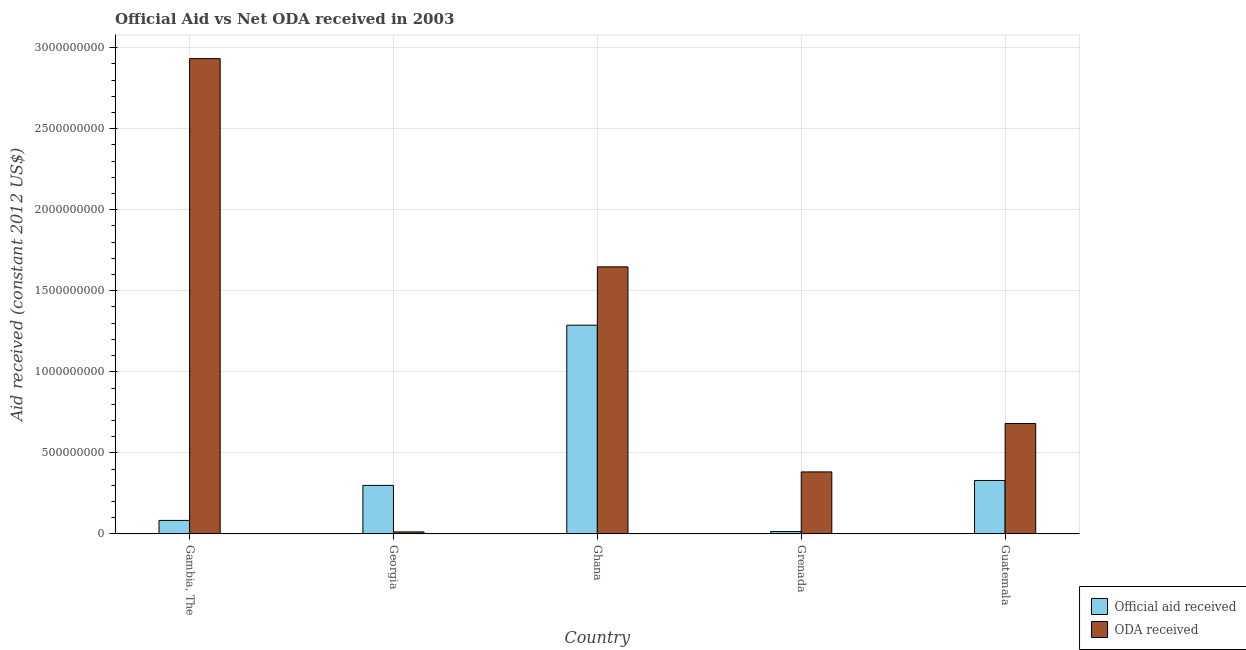How many different coloured bars are there?
Your response must be concise. 2. How many groups of bars are there?
Make the answer very short. 5. Are the number of bars per tick equal to the number of legend labels?
Your response must be concise. Yes. How many bars are there on the 4th tick from the left?
Provide a succinct answer. 2. What is the label of the 4th group of bars from the left?
Offer a terse response. Grenada. What is the official aid received in Grenada?
Make the answer very short. 1.42e+07. Across all countries, what is the maximum official aid received?
Provide a short and direct response. 1.29e+09. Across all countries, what is the minimum official aid received?
Provide a short and direct response. 1.42e+07. In which country was the oda received maximum?
Your answer should be very brief. Gambia, The. In which country was the oda received minimum?
Your answer should be very brief. Georgia. What is the total oda received in the graph?
Your response must be concise. 5.66e+09. What is the difference between the official aid received in Georgia and that in Guatemala?
Provide a short and direct response. -3.03e+07. What is the difference between the oda received in Gambia, The and the official aid received in Ghana?
Your answer should be compact. 1.64e+09. What is the average oda received per country?
Provide a short and direct response. 1.13e+09. What is the difference between the official aid received and oda received in Ghana?
Your answer should be very brief. -3.60e+08. In how many countries, is the official aid received greater than 200000000 US$?
Your response must be concise. 3. What is the ratio of the official aid received in Ghana to that in Guatemala?
Your answer should be compact. 3.91. Is the oda received in Georgia less than that in Ghana?
Make the answer very short. Yes. Is the difference between the official aid received in Georgia and Grenada greater than the difference between the oda received in Georgia and Grenada?
Offer a terse response. Yes. What is the difference between the highest and the second highest official aid received?
Provide a succinct answer. 9.58e+08. What is the difference between the highest and the lowest oda received?
Your response must be concise. 2.92e+09. Is the sum of the oda received in Georgia and Grenada greater than the maximum official aid received across all countries?
Your response must be concise. No. What does the 1st bar from the left in Ghana represents?
Ensure brevity in your answer.  Official aid received. What does the 2nd bar from the right in Ghana represents?
Ensure brevity in your answer.  Official aid received. Where does the legend appear in the graph?
Your answer should be very brief. Bottom right. How many legend labels are there?
Your response must be concise. 2. What is the title of the graph?
Provide a short and direct response. Official Aid vs Net ODA received in 2003 . Does "Food" appear as one of the legend labels in the graph?
Your answer should be very brief. No. What is the label or title of the Y-axis?
Offer a very short reply. Aid received (constant 2012 US$). What is the Aid received (constant 2012 US$) of Official aid received in Gambia, The?
Your answer should be compact. 8.30e+07. What is the Aid received (constant 2012 US$) of ODA received in Gambia, The?
Make the answer very short. 2.93e+09. What is the Aid received (constant 2012 US$) in Official aid received in Georgia?
Provide a short and direct response. 2.99e+08. What is the Aid received (constant 2012 US$) of ODA received in Georgia?
Offer a terse response. 1.21e+07. What is the Aid received (constant 2012 US$) in Official aid received in Ghana?
Your answer should be compact. 1.29e+09. What is the Aid received (constant 2012 US$) in ODA received in Ghana?
Provide a short and direct response. 1.65e+09. What is the Aid received (constant 2012 US$) in Official aid received in Grenada?
Your answer should be very brief. 1.42e+07. What is the Aid received (constant 2012 US$) of ODA received in Grenada?
Your response must be concise. 3.82e+08. What is the Aid received (constant 2012 US$) in Official aid received in Guatemala?
Make the answer very short. 3.29e+08. What is the Aid received (constant 2012 US$) in ODA received in Guatemala?
Ensure brevity in your answer.  6.81e+08. Across all countries, what is the maximum Aid received (constant 2012 US$) in Official aid received?
Offer a terse response. 1.29e+09. Across all countries, what is the maximum Aid received (constant 2012 US$) in ODA received?
Make the answer very short. 2.93e+09. Across all countries, what is the minimum Aid received (constant 2012 US$) of Official aid received?
Provide a short and direct response. 1.42e+07. Across all countries, what is the minimum Aid received (constant 2012 US$) of ODA received?
Provide a short and direct response. 1.21e+07. What is the total Aid received (constant 2012 US$) in Official aid received in the graph?
Your answer should be very brief. 2.01e+09. What is the total Aid received (constant 2012 US$) of ODA received in the graph?
Your response must be concise. 5.66e+09. What is the difference between the Aid received (constant 2012 US$) of Official aid received in Gambia, The and that in Georgia?
Ensure brevity in your answer.  -2.16e+08. What is the difference between the Aid received (constant 2012 US$) of ODA received in Gambia, The and that in Georgia?
Your response must be concise. 2.92e+09. What is the difference between the Aid received (constant 2012 US$) of Official aid received in Gambia, The and that in Ghana?
Make the answer very short. -1.20e+09. What is the difference between the Aid received (constant 2012 US$) in ODA received in Gambia, The and that in Ghana?
Your answer should be compact. 1.28e+09. What is the difference between the Aid received (constant 2012 US$) of Official aid received in Gambia, The and that in Grenada?
Offer a terse response. 6.88e+07. What is the difference between the Aid received (constant 2012 US$) of ODA received in Gambia, The and that in Grenada?
Offer a terse response. 2.55e+09. What is the difference between the Aid received (constant 2012 US$) in Official aid received in Gambia, The and that in Guatemala?
Your answer should be very brief. -2.46e+08. What is the difference between the Aid received (constant 2012 US$) of ODA received in Gambia, The and that in Guatemala?
Offer a very short reply. 2.25e+09. What is the difference between the Aid received (constant 2012 US$) of Official aid received in Georgia and that in Ghana?
Make the answer very short. -9.89e+08. What is the difference between the Aid received (constant 2012 US$) of ODA received in Georgia and that in Ghana?
Your response must be concise. -1.64e+09. What is the difference between the Aid received (constant 2012 US$) in Official aid received in Georgia and that in Grenada?
Offer a very short reply. 2.85e+08. What is the difference between the Aid received (constant 2012 US$) of ODA received in Georgia and that in Grenada?
Your answer should be very brief. -3.70e+08. What is the difference between the Aid received (constant 2012 US$) in Official aid received in Georgia and that in Guatemala?
Your answer should be compact. -3.03e+07. What is the difference between the Aid received (constant 2012 US$) of ODA received in Georgia and that in Guatemala?
Ensure brevity in your answer.  -6.69e+08. What is the difference between the Aid received (constant 2012 US$) of Official aid received in Ghana and that in Grenada?
Ensure brevity in your answer.  1.27e+09. What is the difference between the Aid received (constant 2012 US$) in ODA received in Ghana and that in Grenada?
Ensure brevity in your answer.  1.27e+09. What is the difference between the Aid received (constant 2012 US$) of Official aid received in Ghana and that in Guatemala?
Make the answer very short. 9.58e+08. What is the difference between the Aid received (constant 2012 US$) of ODA received in Ghana and that in Guatemala?
Ensure brevity in your answer.  9.67e+08. What is the difference between the Aid received (constant 2012 US$) of Official aid received in Grenada and that in Guatemala?
Keep it short and to the point. -3.15e+08. What is the difference between the Aid received (constant 2012 US$) in ODA received in Grenada and that in Guatemala?
Keep it short and to the point. -2.99e+08. What is the difference between the Aid received (constant 2012 US$) in Official aid received in Gambia, The and the Aid received (constant 2012 US$) in ODA received in Georgia?
Offer a terse response. 7.09e+07. What is the difference between the Aid received (constant 2012 US$) of Official aid received in Gambia, The and the Aid received (constant 2012 US$) of ODA received in Ghana?
Your answer should be very brief. -1.56e+09. What is the difference between the Aid received (constant 2012 US$) in Official aid received in Gambia, The and the Aid received (constant 2012 US$) in ODA received in Grenada?
Your answer should be very brief. -2.99e+08. What is the difference between the Aid received (constant 2012 US$) of Official aid received in Gambia, The and the Aid received (constant 2012 US$) of ODA received in Guatemala?
Offer a terse response. -5.98e+08. What is the difference between the Aid received (constant 2012 US$) in Official aid received in Georgia and the Aid received (constant 2012 US$) in ODA received in Ghana?
Offer a terse response. -1.35e+09. What is the difference between the Aid received (constant 2012 US$) in Official aid received in Georgia and the Aid received (constant 2012 US$) in ODA received in Grenada?
Ensure brevity in your answer.  -8.31e+07. What is the difference between the Aid received (constant 2012 US$) of Official aid received in Georgia and the Aid received (constant 2012 US$) of ODA received in Guatemala?
Your response must be concise. -3.82e+08. What is the difference between the Aid received (constant 2012 US$) of Official aid received in Ghana and the Aid received (constant 2012 US$) of ODA received in Grenada?
Keep it short and to the point. 9.05e+08. What is the difference between the Aid received (constant 2012 US$) of Official aid received in Ghana and the Aid received (constant 2012 US$) of ODA received in Guatemala?
Provide a short and direct response. 6.07e+08. What is the difference between the Aid received (constant 2012 US$) in Official aid received in Grenada and the Aid received (constant 2012 US$) in ODA received in Guatemala?
Offer a terse response. -6.67e+08. What is the average Aid received (constant 2012 US$) in Official aid received per country?
Provide a succinct answer. 4.03e+08. What is the average Aid received (constant 2012 US$) in ODA received per country?
Provide a short and direct response. 1.13e+09. What is the difference between the Aid received (constant 2012 US$) of Official aid received and Aid received (constant 2012 US$) of ODA received in Gambia, The?
Your answer should be very brief. -2.85e+09. What is the difference between the Aid received (constant 2012 US$) of Official aid received and Aid received (constant 2012 US$) of ODA received in Georgia?
Keep it short and to the point. 2.87e+08. What is the difference between the Aid received (constant 2012 US$) of Official aid received and Aid received (constant 2012 US$) of ODA received in Ghana?
Offer a very short reply. -3.60e+08. What is the difference between the Aid received (constant 2012 US$) of Official aid received and Aid received (constant 2012 US$) of ODA received in Grenada?
Your response must be concise. -3.68e+08. What is the difference between the Aid received (constant 2012 US$) in Official aid received and Aid received (constant 2012 US$) in ODA received in Guatemala?
Your answer should be compact. -3.52e+08. What is the ratio of the Aid received (constant 2012 US$) in Official aid received in Gambia, The to that in Georgia?
Your answer should be very brief. 0.28. What is the ratio of the Aid received (constant 2012 US$) in ODA received in Gambia, The to that in Georgia?
Offer a terse response. 242.97. What is the ratio of the Aid received (constant 2012 US$) of Official aid received in Gambia, The to that in Ghana?
Offer a terse response. 0.06. What is the ratio of the Aid received (constant 2012 US$) in ODA received in Gambia, The to that in Ghana?
Your answer should be very brief. 1.78. What is the ratio of the Aid received (constant 2012 US$) in Official aid received in Gambia, The to that in Grenada?
Provide a short and direct response. 5.85. What is the ratio of the Aid received (constant 2012 US$) in ODA received in Gambia, The to that in Grenada?
Make the answer very short. 7.67. What is the ratio of the Aid received (constant 2012 US$) of Official aid received in Gambia, The to that in Guatemala?
Provide a succinct answer. 0.25. What is the ratio of the Aid received (constant 2012 US$) of ODA received in Gambia, The to that in Guatemala?
Offer a very short reply. 4.31. What is the ratio of the Aid received (constant 2012 US$) of Official aid received in Georgia to that in Ghana?
Make the answer very short. 0.23. What is the ratio of the Aid received (constant 2012 US$) of ODA received in Georgia to that in Ghana?
Make the answer very short. 0.01. What is the ratio of the Aid received (constant 2012 US$) in Official aid received in Georgia to that in Grenada?
Your answer should be very brief. 21.07. What is the ratio of the Aid received (constant 2012 US$) of ODA received in Georgia to that in Grenada?
Offer a very short reply. 0.03. What is the ratio of the Aid received (constant 2012 US$) in Official aid received in Georgia to that in Guatemala?
Your answer should be compact. 0.91. What is the ratio of the Aid received (constant 2012 US$) in ODA received in Georgia to that in Guatemala?
Provide a short and direct response. 0.02. What is the ratio of the Aid received (constant 2012 US$) in Official aid received in Ghana to that in Grenada?
Provide a succinct answer. 90.69. What is the ratio of the Aid received (constant 2012 US$) of ODA received in Ghana to that in Grenada?
Provide a succinct answer. 4.31. What is the ratio of the Aid received (constant 2012 US$) of Official aid received in Ghana to that in Guatemala?
Offer a terse response. 3.91. What is the ratio of the Aid received (constant 2012 US$) of ODA received in Ghana to that in Guatemala?
Provide a short and direct response. 2.42. What is the ratio of the Aid received (constant 2012 US$) in Official aid received in Grenada to that in Guatemala?
Your answer should be very brief. 0.04. What is the ratio of the Aid received (constant 2012 US$) of ODA received in Grenada to that in Guatemala?
Your response must be concise. 0.56. What is the difference between the highest and the second highest Aid received (constant 2012 US$) of Official aid received?
Offer a terse response. 9.58e+08. What is the difference between the highest and the second highest Aid received (constant 2012 US$) of ODA received?
Make the answer very short. 1.28e+09. What is the difference between the highest and the lowest Aid received (constant 2012 US$) in Official aid received?
Your answer should be very brief. 1.27e+09. What is the difference between the highest and the lowest Aid received (constant 2012 US$) in ODA received?
Your answer should be compact. 2.92e+09. 